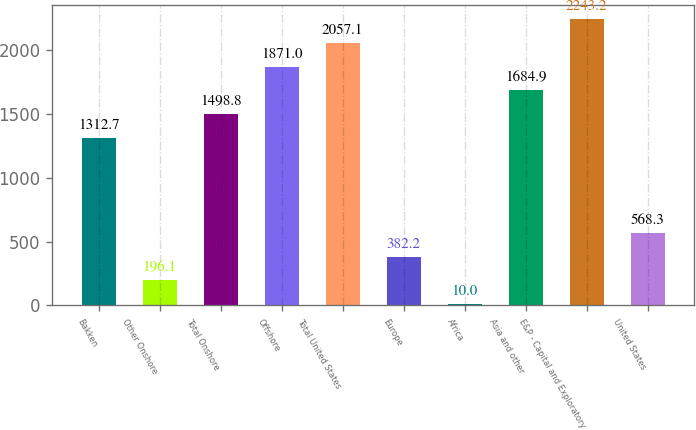Convert chart. <chart><loc_0><loc_0><loc_500><loc_500><bar_chart><fcel>Bakken<fcel>Other Onshore<fcel>Total Onshore<fcel>Offshore<fcel>Total United States<fcel>Europe<fcel>Africa<fcel>Asia and other<fcel>E&P - Capital and Exploratory<fcel>United States<nl><fcel>1312.7<fcel>196.1<fcel>1498.8<fcel>1871<fcel>2057.1<fcel>382.2<fcel>10<fcel>1684.9<fcel>2243.2<fcel>568.3<nl></chart> 